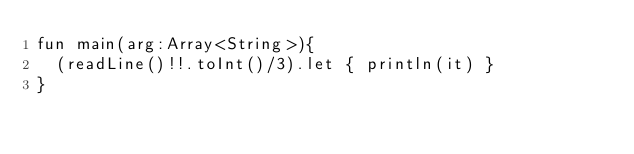Convert code to text. <code><loc_0><loc_0><loc_500><loc_500><_Kotlin_>fun main(arg:Array<String>){
  (readLine()!!.toInt()/3).let { println(it) }
}</code> 